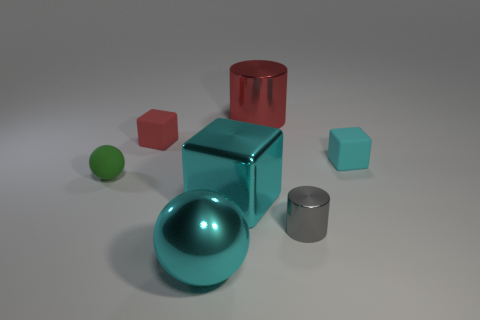Add 3 tiny red rubber balls. How many objects exist? 10 Subtract all blocks. How many objects are left? 4 Add 7 cyan metal cubes. How many cyan metal cubes exist? 8 Subtract 0 brown cylinders. How many objects are left? 7 Subtract all big gray spheres. Subtract all blocks. How many objects are left? 4 Add 2 shiny spheres. How many shiny spheres are left? 3 